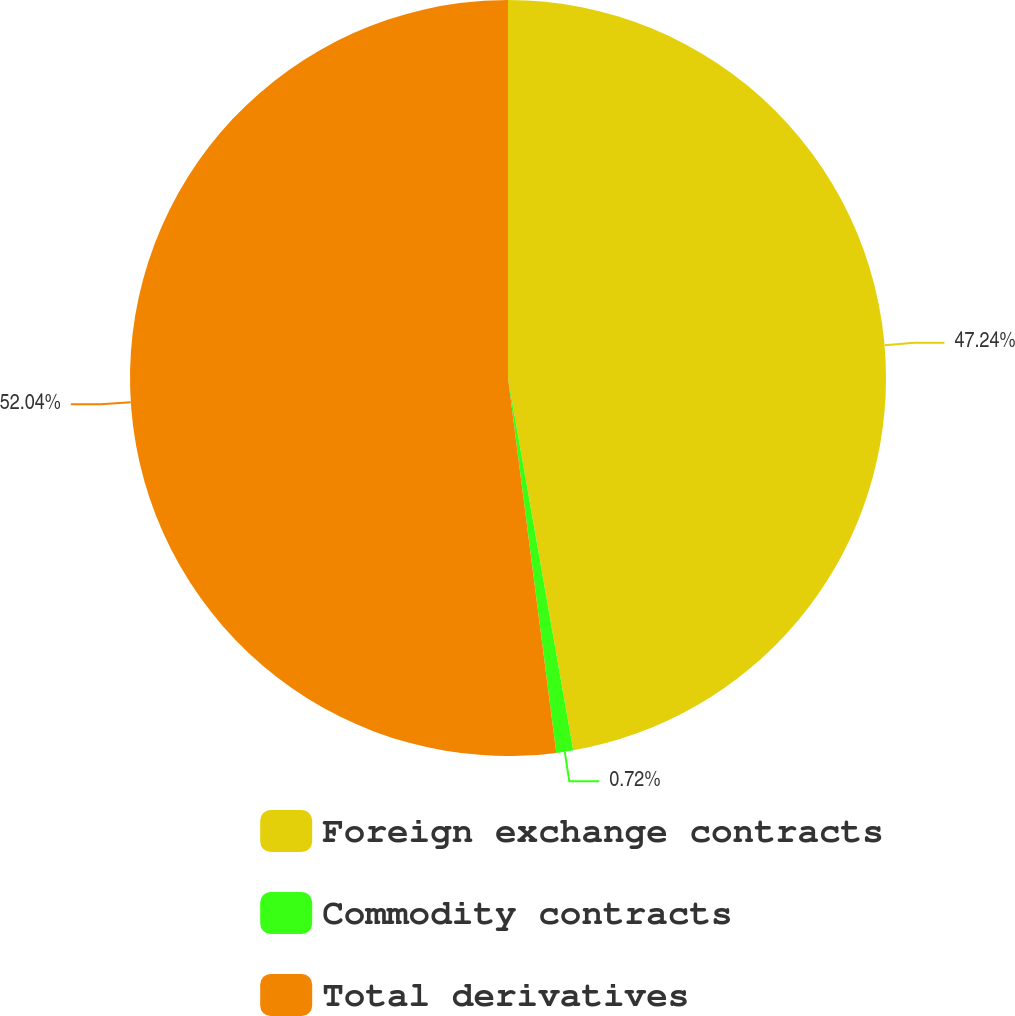<chart> <loc_0><loc_0><loc_500><loc_500><pie_chart><fcel>Foreign exchange contracts<fcel>Commodity contracts<fcel>Total derivatives<nl><fcel>47.24%<fcel>0.72%<fcel>52.04%<nl></chart> 